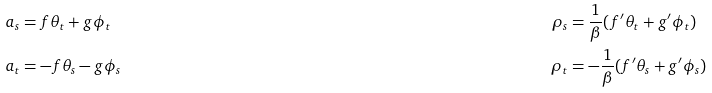Convert formula to latex. <formula><loc_0><loc_0><loc_500><loc_500>a _ { s } & = f \theta _ { t } + g \phi _ { t } \quad & \rho _ { s } & = \frac { 1 } { \beta } ( f ^ { \prime } \theta _ { t } + g ^ { \prime } \phi _ { t } ) \\ a _ { t } & = - f \theta _ { s } - g \phi _ { s } & \rho _ { t } & = - \frac { 1 } { \beta } ( f ^ { \prime } \theta _ { s } + g ^ { \prime } \phi _ { s } ) \\</formula> 